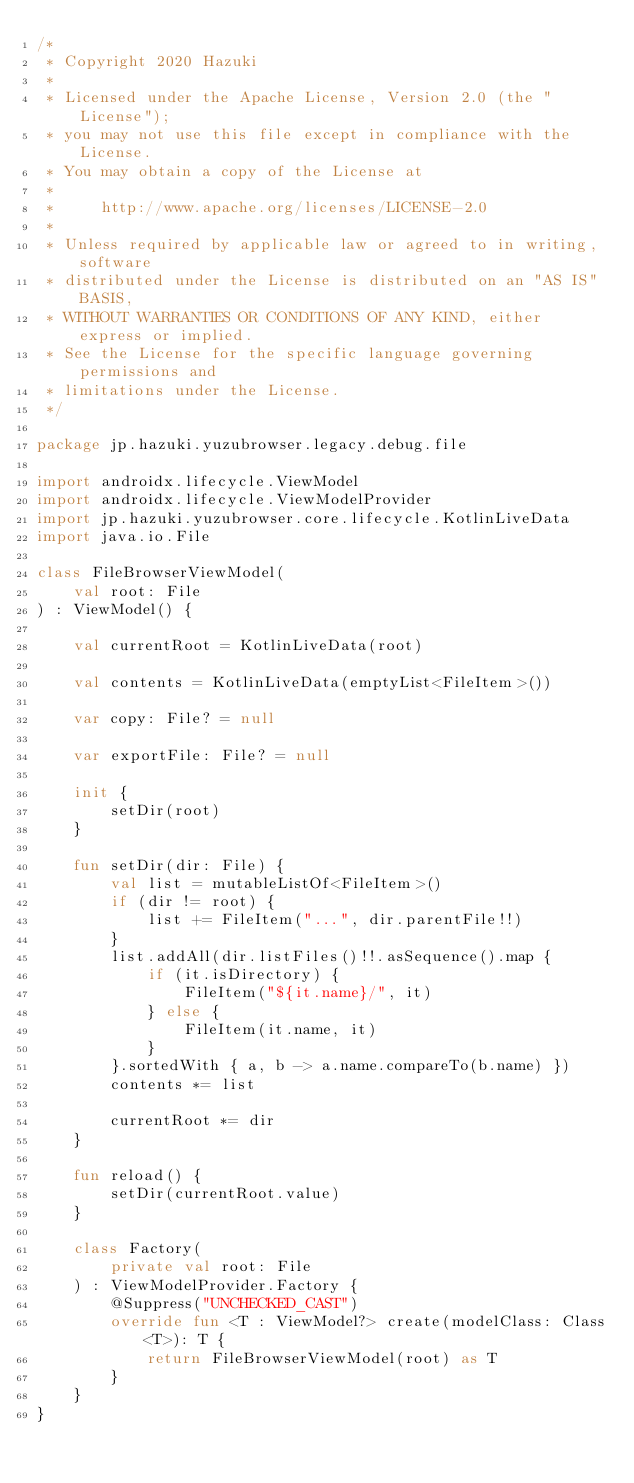<code> <loc_0><loc_0><loc_500><loc_500><_Kotlin_>/*
 * Copyright 2020 Hazuki
 *
 * Licensed under the Apache License, Version 2.0 (the "License");
 * you may not use this file except in compliance with the License.
 * You may obtain a copy of the License at
 *
 *     http://www.apache.org/licenses/LICENSE-2.0
 *
 * Unless required by applicable law or agreed to in writing, software
 * distributed under the License is distributed on an "AS IS" BASIS,
 * WITHOUT WARRANTIES OR CONDITIONS OF ANY KIND, either express or implied.
 * See the License for the specific language governing permissions and
 * limitations under the License.
 */

package jp.hazuki.yuzubrowser.legacy.debug.file

import androidx.lifecycle.ViewModel
import androidx.lifecycle.ViewModelProvider
import jp.hazuki.yuzubrowser.core.lifecycle.KotlinLiveData
import java.io.File

class FileBrowserViewModel(
    val root: File
) : ViewModel() {

    val currentRoot = KotlinLiveData(root)

    val contents = KotlinLiveData(emptyList<FileItem>())

    var copy: File? = null

    var exportFile: File? = null

    init {
        setDir(root)
    }

    fun setDir(dir: File) {
        val list = mutableListOf<FileItem>()
        if (dir != root) {
            list += FileItem("...", dir.parentFile!!)
        }
        list.addAll(dir.listFiles()!!.asSequence().map {
            if (it.isDirectory) {
                FileItem("${it.name}/", it)
            } else {
                FileItem(it.name, it)
            }
        }.sortedWith { a, b -> a.name.compareTo(b.name) })
        contents *= list

        currentRoot *= dir
    }

    fun reload() {
        setDir(currentRoot.value)
    }

    class Factory(
        private val root: File
    ) : ViewModelProvider.Factory {
        @Suppress("UNCHECKED_CAST")
        override fun <T : ViewModel?> create(modelClass: Class<T>): T {
            return FileBrowserViewModel(root) as T
        }
    }
}
</code> 